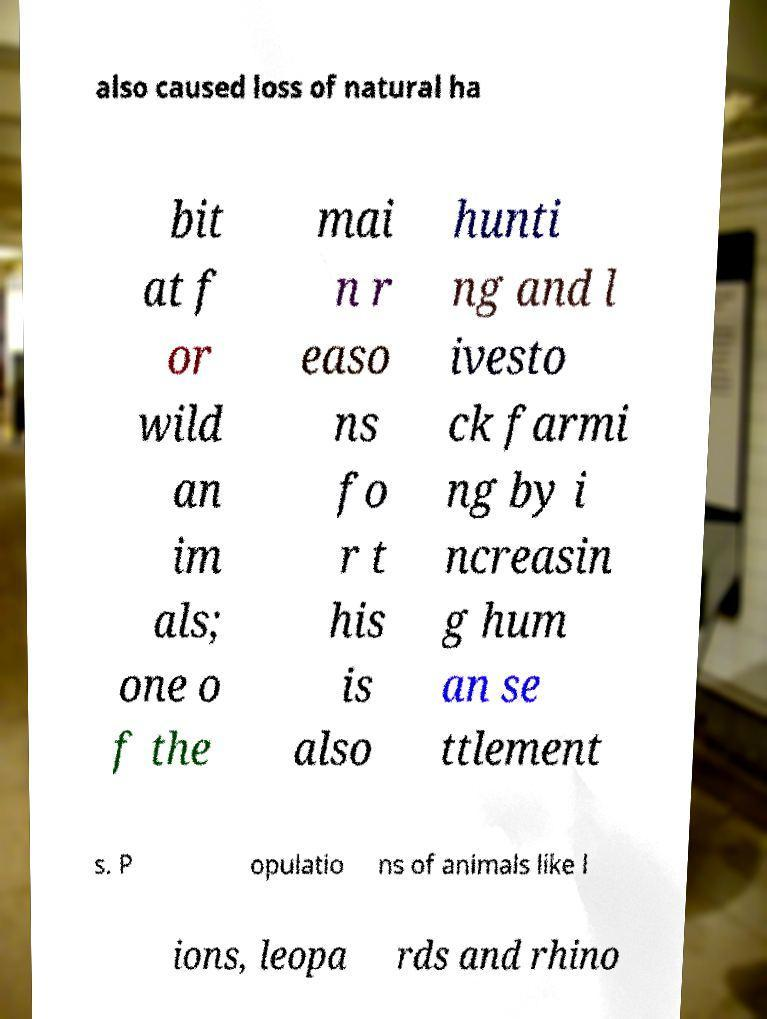Please identify and transcribe the text found in this image. also caused loss of natural ha bit at f or wild an im als; one o f the mai n r easo ns fo r t his is also hunti ng and l ivesto ck farmi ng by i ncreasin g hum an se ttlement s. P opulatio ns of animals like l ions, leopa rds and rhino 